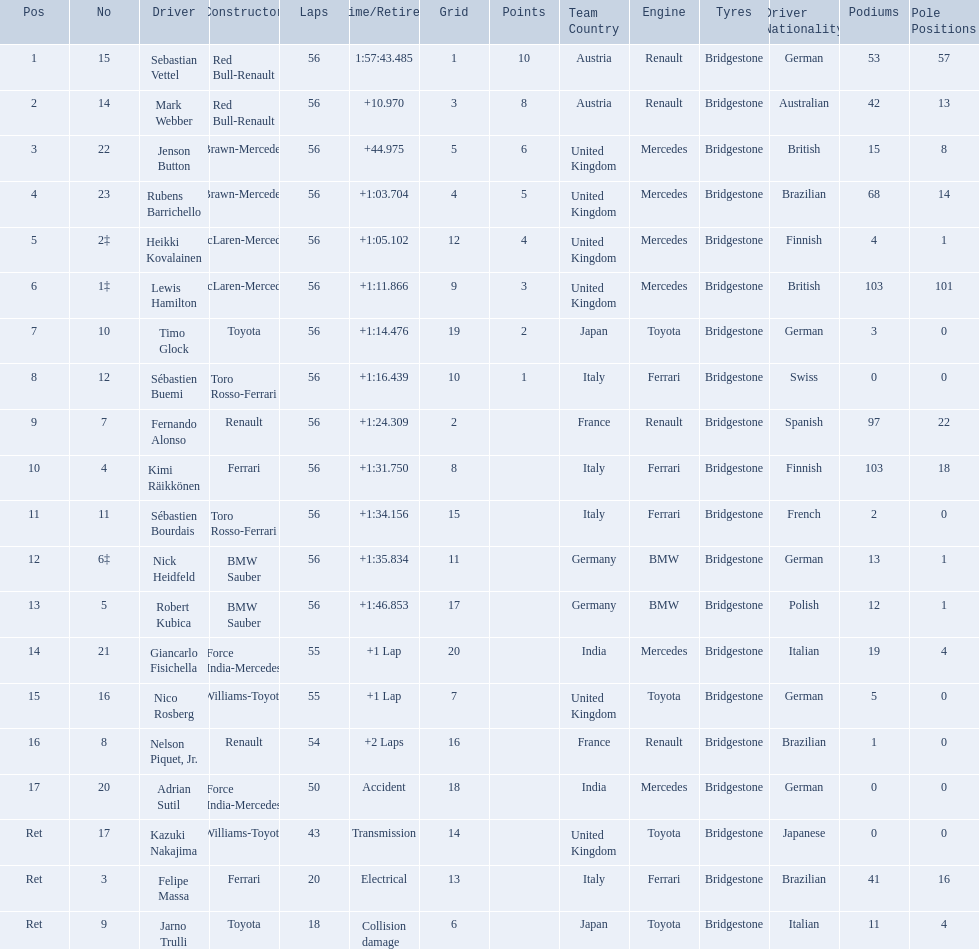Who are all the drivers? Sebastian Vettel, Mark Webber, Jenson Button, Rubens Barrichello, Heikki Kovalainen, Lewis Hamilton, Timo Glock, Sébastien Buemi, Fernando Alonso, Kimi Räikkönen, Sébastien Bourdais, Nick Heidfeld, Robert Kubica, Giancarlo Fisichella, Nico Rosberg, Nelson Piquet, Jr., Adrian Sutil, Kazuki Nakajima, Felipe Massa, Jarno Trulli. What were their finishing times? 1:57:43.485, +10.970, +44.975, +1:03.704, +1:05.102, +1:11.866, +1:14.476, +1:16.439, +1:24.309, +1:31.750, +1:34.156, +1:35.834, +1:46.853, +1 Lap, +1 Lap, +2 Laps, Accident, Transmission, Electrical, Collision damage. Who finished last? Robert Kubica. 